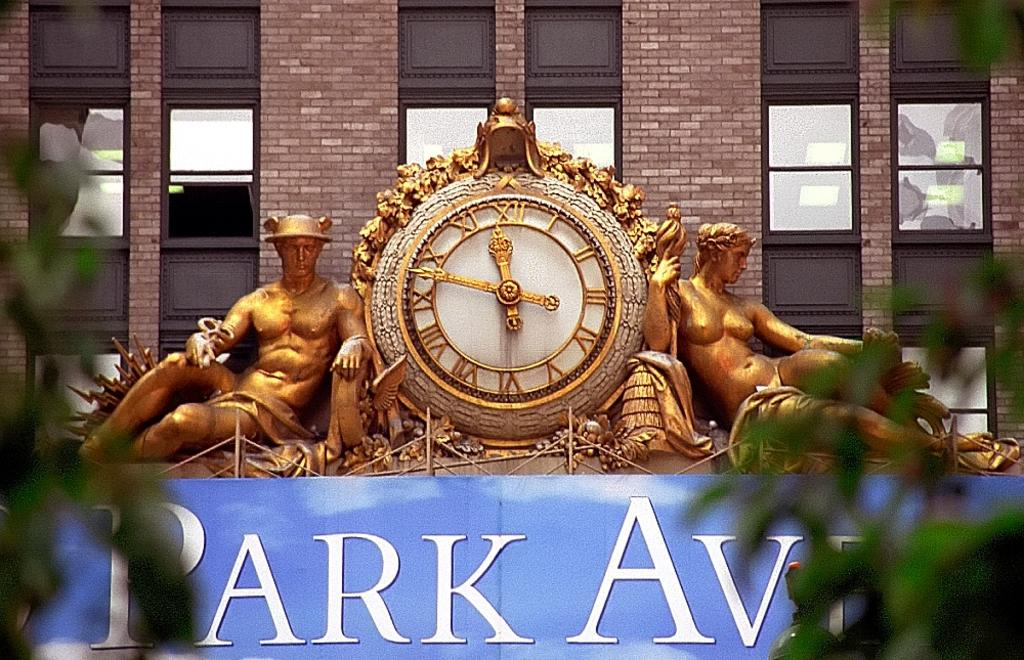<image>
Relay a brief, clear account of the picture shown. Small clock above a sign that says PARK AVE. 